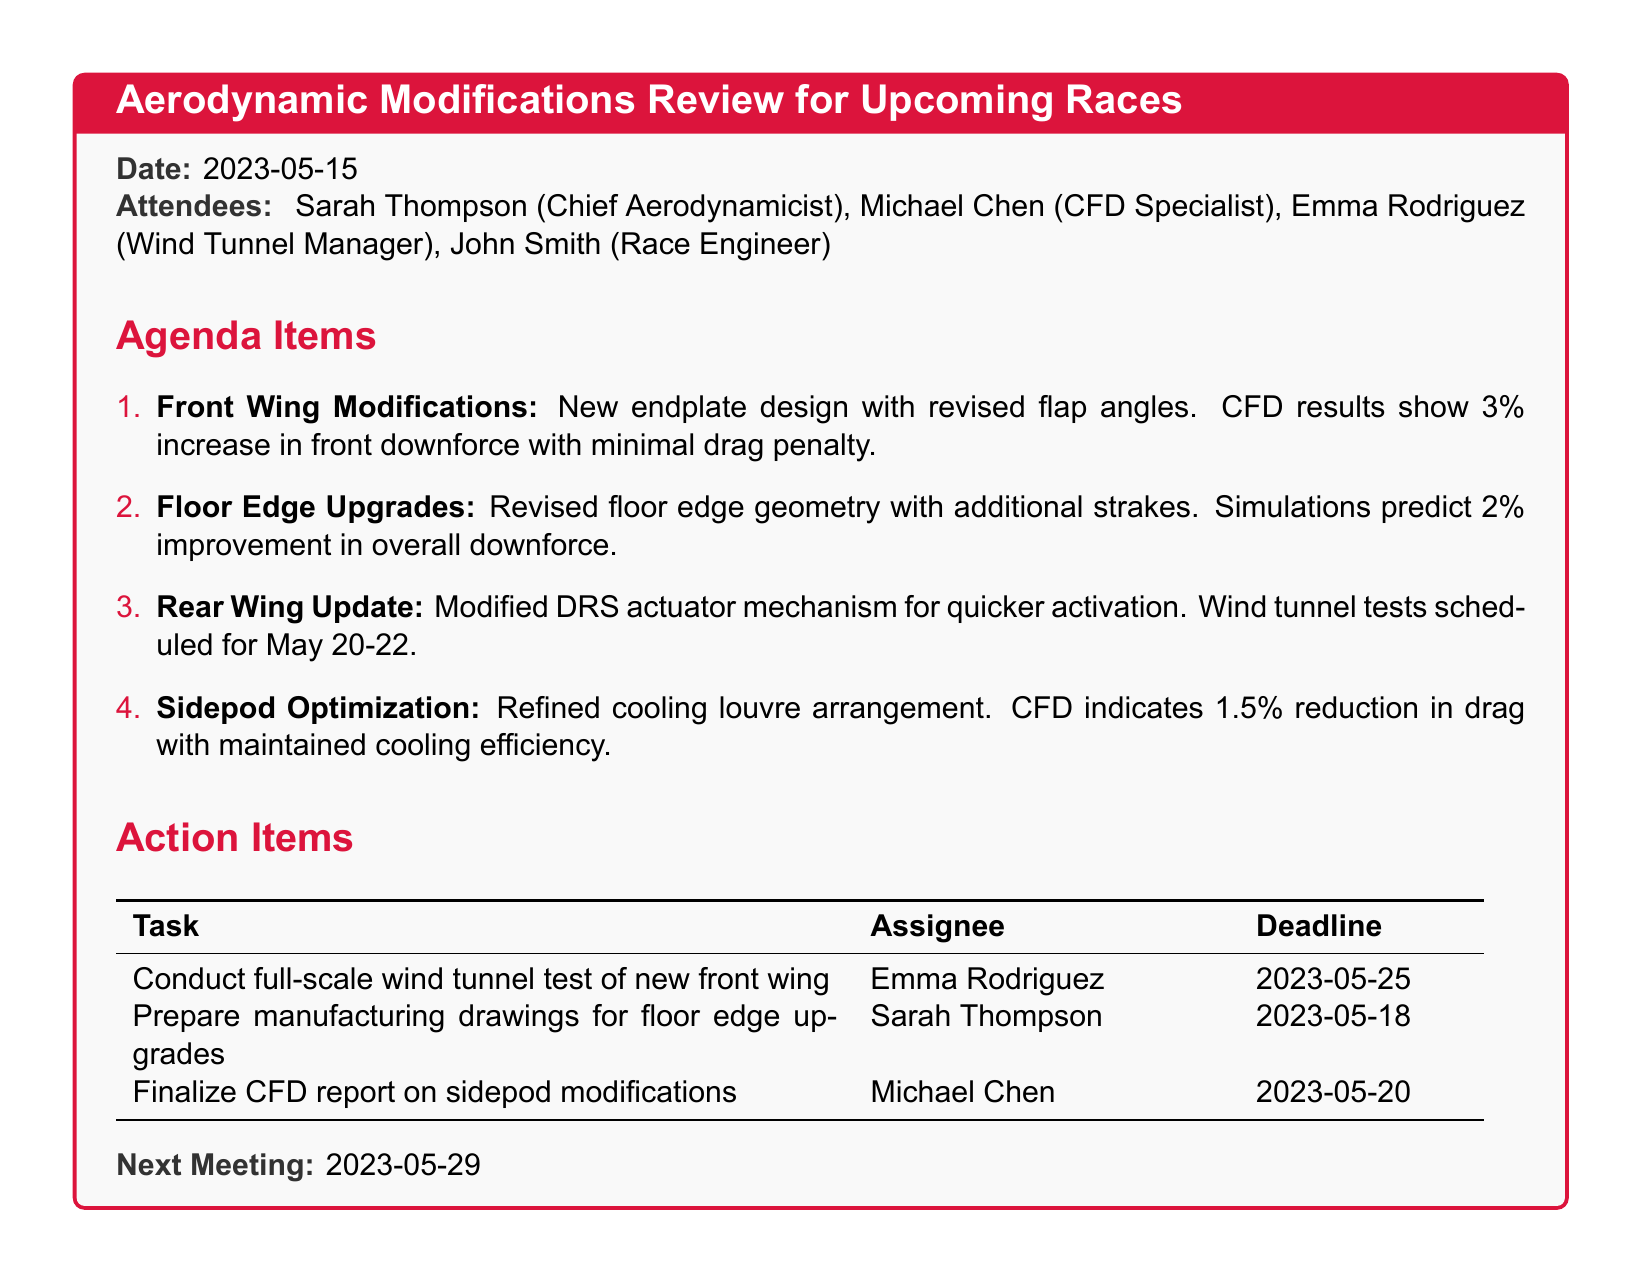What is the date of the meeting? The date of the meeting is stated in the document.
Answer: 2023-05-15 Who is the Chief Aerodynamicist? The Chief Aerodynamicist is listed among the attendees.
Answer: Sarah Thompson What percentage increase in front downforce is predicted from front wing modifications? The document outlines the CFD results for front wing modifications.
Answer: 3% When are the wind tunnel tests for the rear wing scheduled? The schedule for wind tunnel tests is clearly mentioned.
Answer: May 20-22 What task is assigned to Emma Rodriguez? The action items include specific tasks assigned to each person.
Answer: Conduct full-scale wind tunnel test of new front wing How much improvement in overall downforce is predicted for floor edge upgrades? The improvements for floor edge upgrades are listed in the agenda items.
Answer: 2% How many attendees are listed in the meeting? The total number of attendees is mentioned in the list.
Answer: Four What is the deadline for finalizing the CFD report on sidepod modifications? The deadlines for action items are provided in the document.
Answer: 2023-05-20 What is the next meeting date? The next meeting date is specified at the end of the document.
Answer: 2023-05-29 